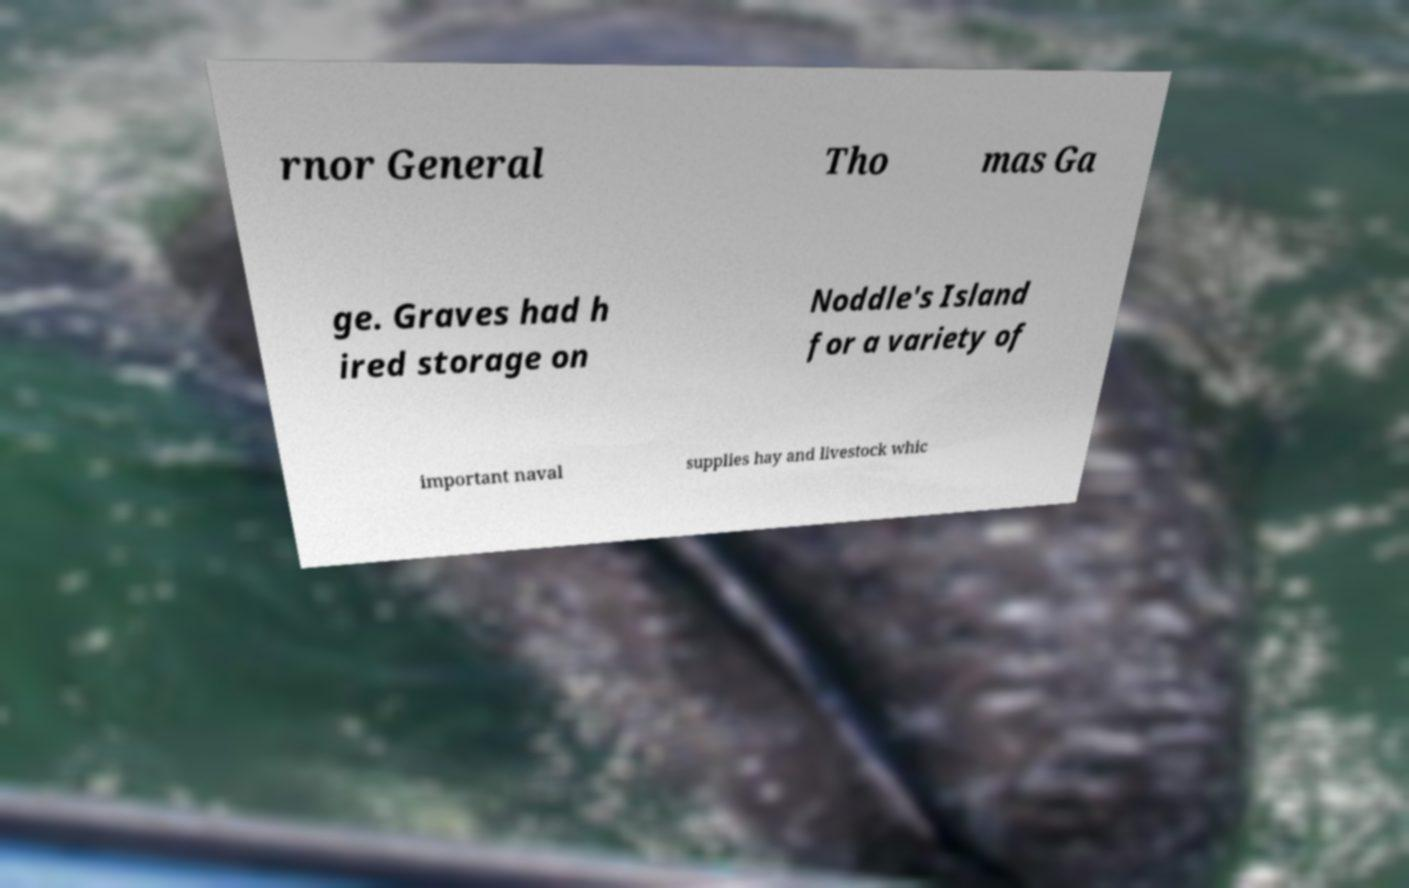What messages or text are displayed in this image? I need them in a readable, typed format. rnor General Tho mas Ga ge. Graves had h ired storage on Noddle's Island for a variety of important naval supplies hay and livestock whic 